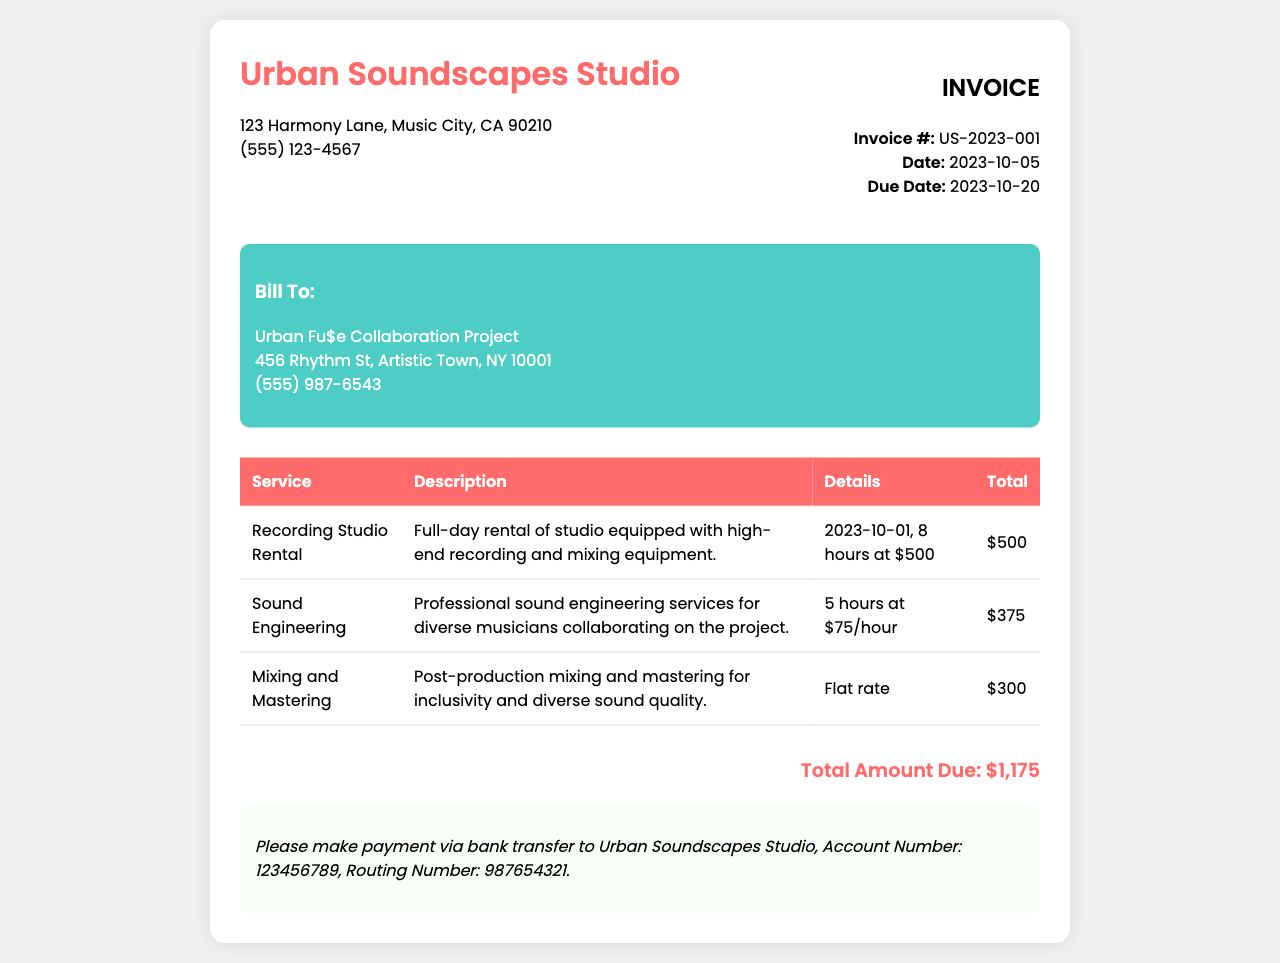what is the invoice number? The invoice number is specified in the document under the invoice information section as US-2023-001.
Answer: US-2023-001 what is the total amount due? The total amount due is calculated and displayed at the bottom of the invoice as $1,175.
Answer: $1,175 who is billed for this invoice? The billing information is found in the "Bill To" section, indicating Urban Fu$e Collaboration Project is being billed.
Answer: Urban Fu$e Collaboration Project what is the date of the invoice? The date of the invoice is mentioned in the document, and it is 2023-10-05.
Answer: 2023-10-05 how many hours of sound engineering services were provided? The number of hours for sound engineering is noted in the description as 5 hours.
Answer: 5 hours what service was provided for a flat rate? The service listed with a flat rate is "Mixing and Mastering."
Answer: Mixing and Mastering when is the payment due? The due date is provided in the invoice details as 2023-10-20.
Answer: 2023-10-20 what is the address of the studio? The studio address is given in the header section as 123 Harmony Lane, Music City, CA 90210.
Answer: 123 Harmony Lane, Music City, CA 90210 what is the hourly rate for sound engineering? The hourly rate for sound engineering services is indicated in the document as $75/hour.
Answer: $75/hour 